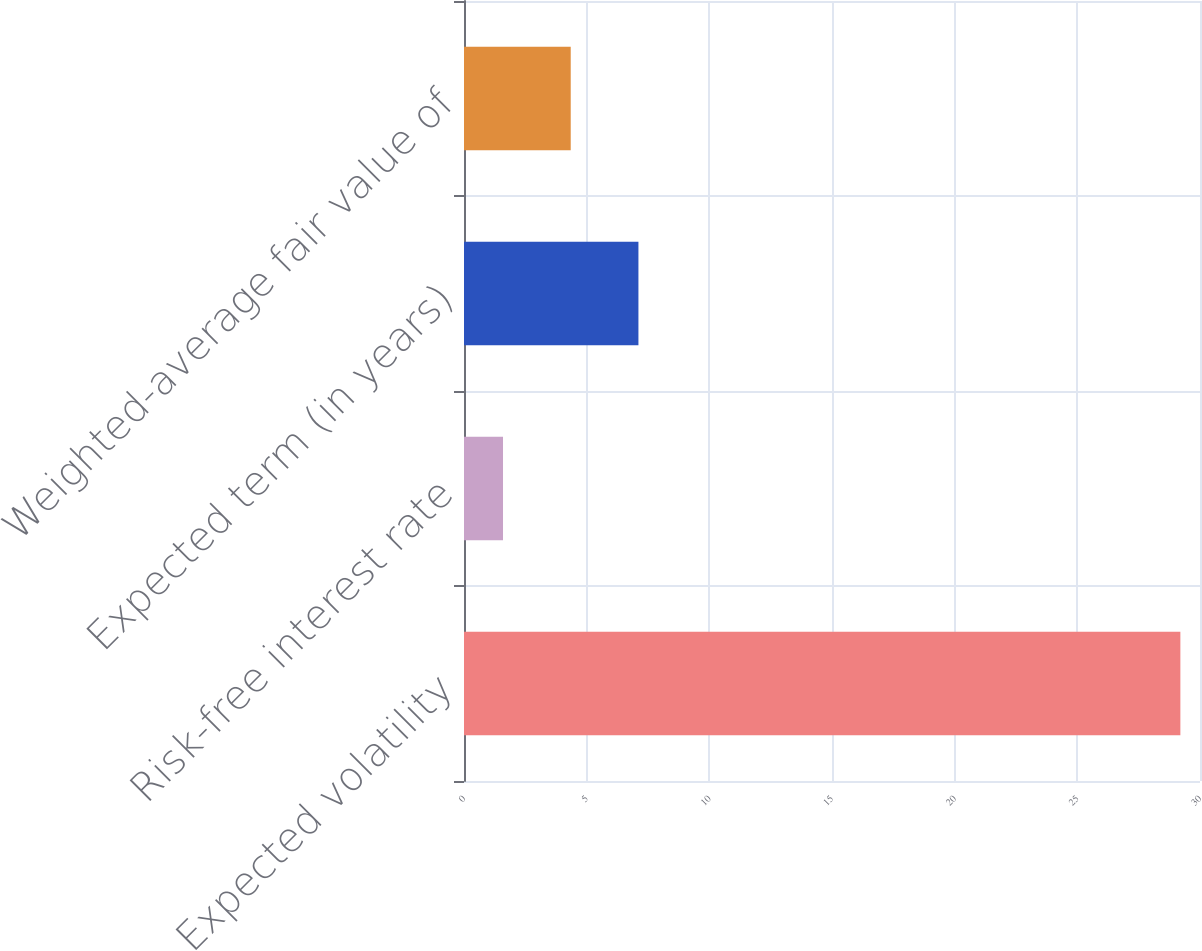<chart> <loc_0><loc_0><loc_500><loc_500><bar_chart><fcel>Expected volatility<fcel>Risk-free interest rate<fcel>Expected term (in years)<fcel>Weighted-average fair value of<nl><fcel>29.2<fcel>1.59<fcel>7.11<fcel>4.35<nl></chart> 